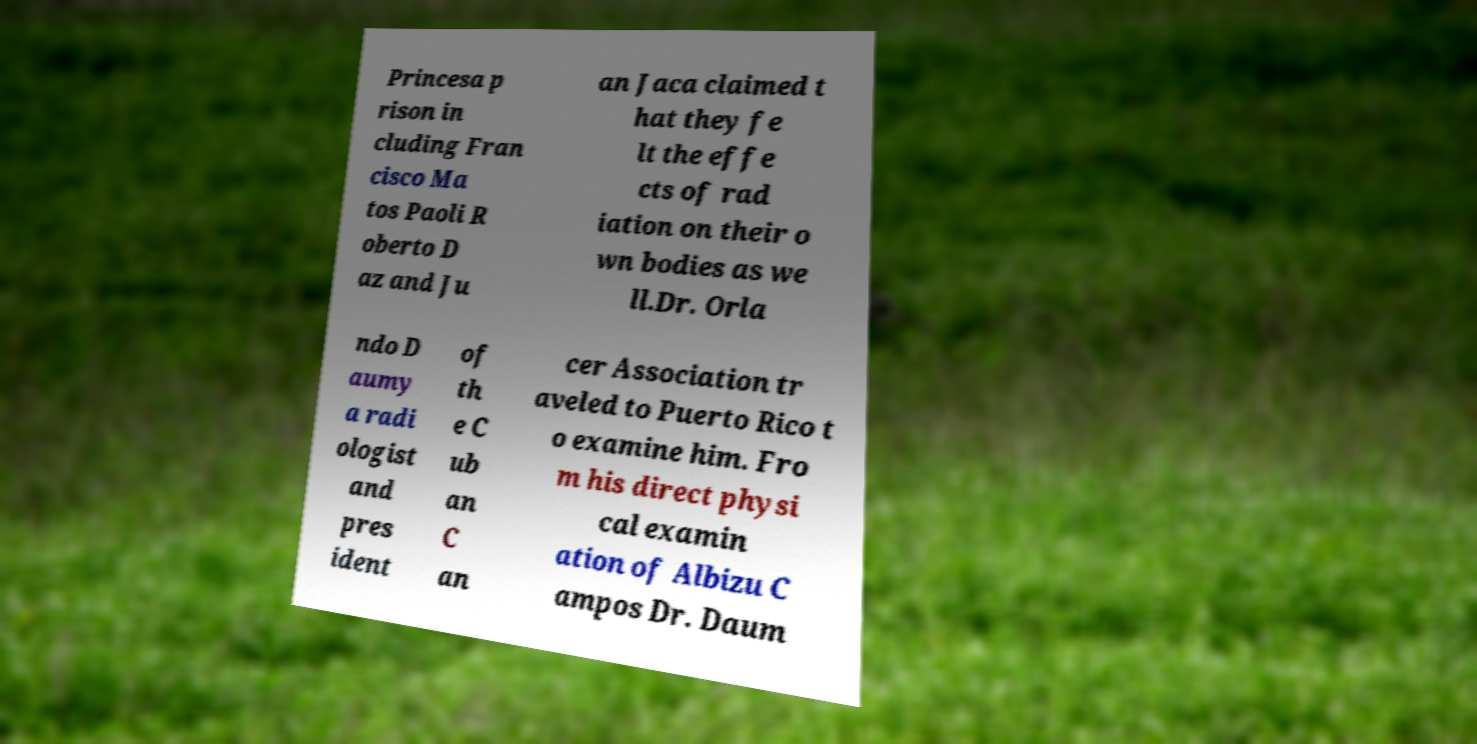Please read and relay the text visible in this image. What does it say? Princesa p rison in cluding Fran cisco Ma tos Paoli R oberto D az and Ju an Jaca claimed t hat they fe lt the effe cts of rad iation on their o wn bodies as we ll.Dr. Orla ndo D aumy a radi ologist and pres ident of th e C ub an C an cer Association tr aveled to Puerto Rico t o examine him. Fro m his direct physi cal examin ation of Albizu C ampos Dr. Daum 